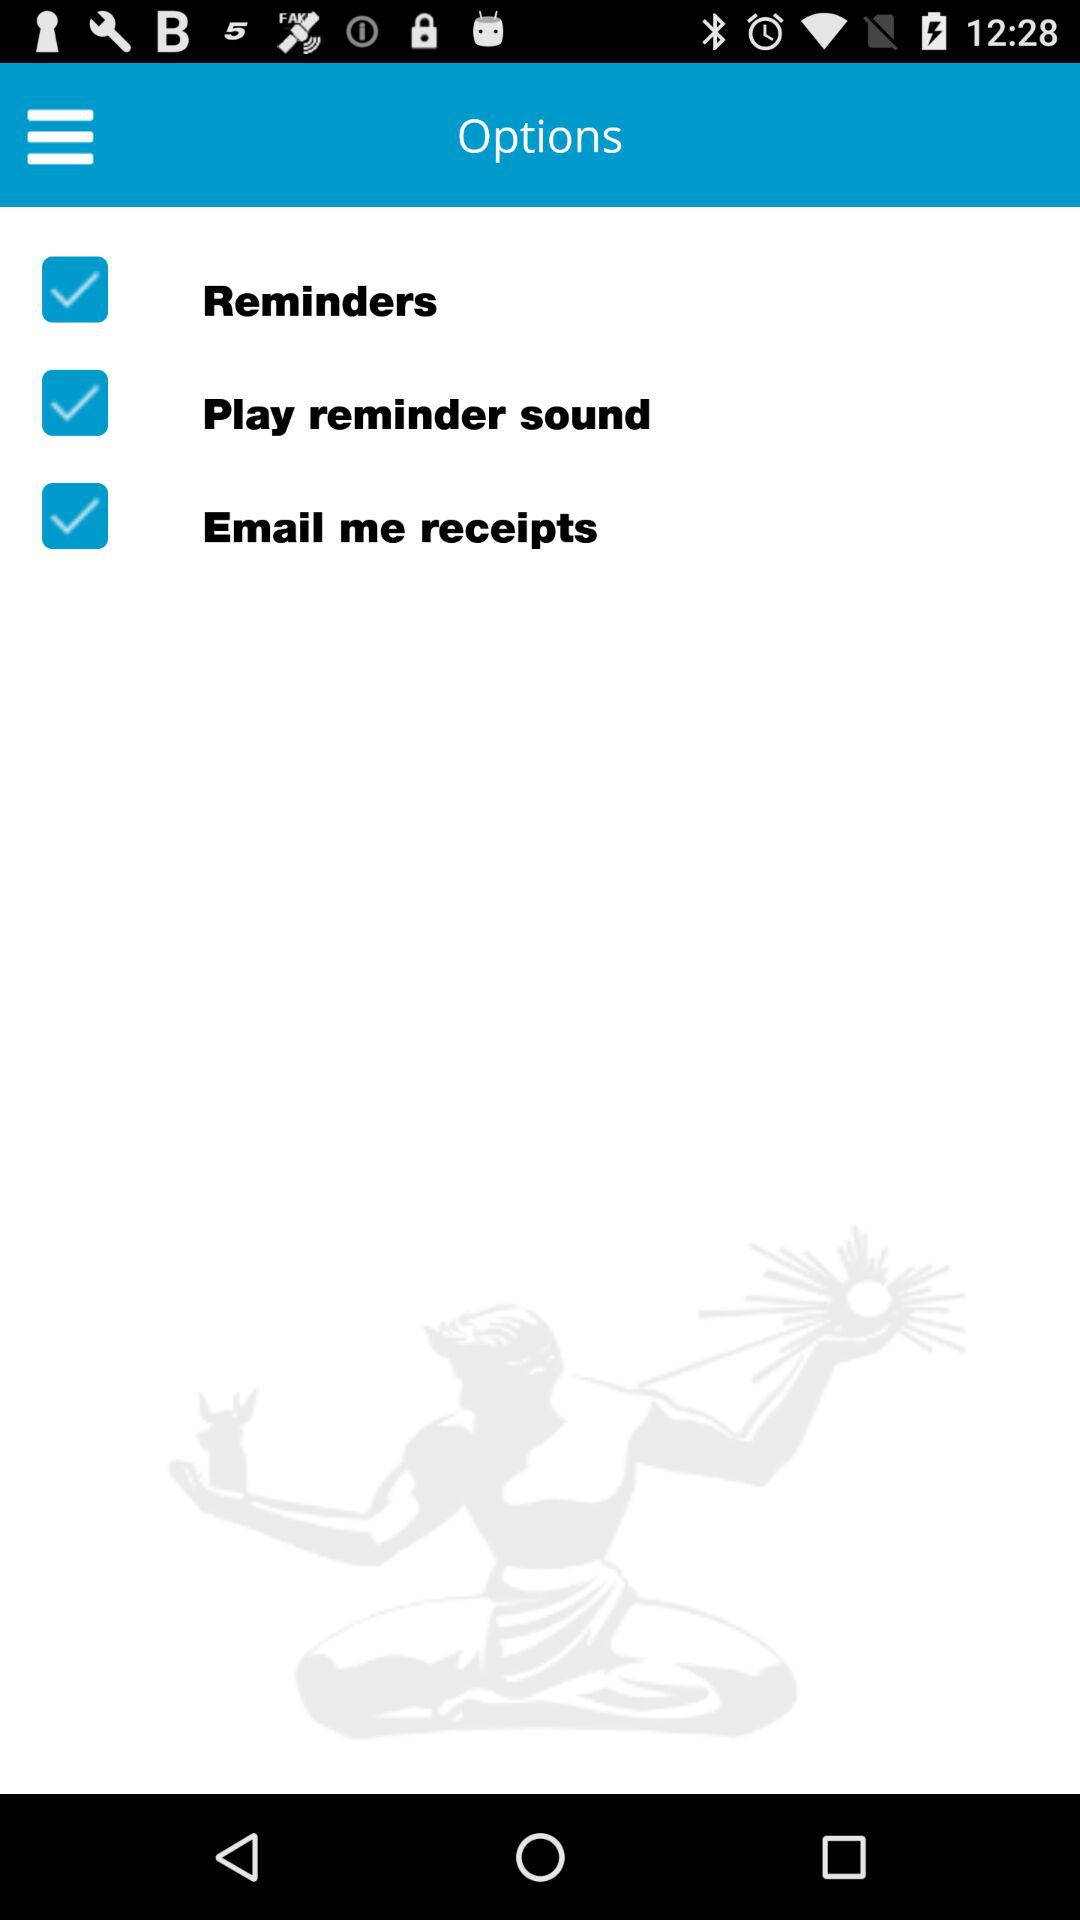Which are the selected options? The selected options are "Reminders", "Play reminder sound" and "Email me receipts". 